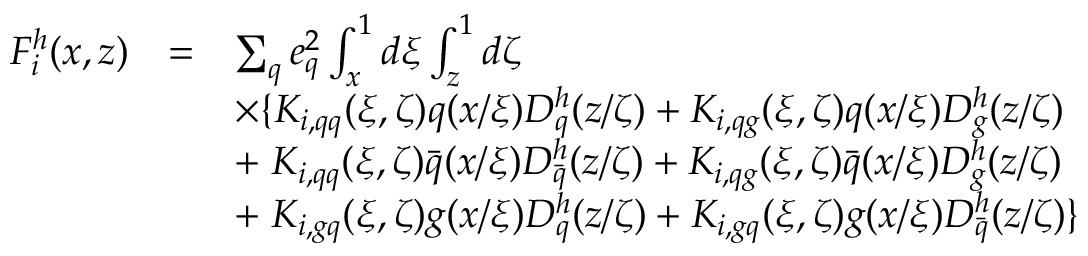Convert formula to latex. <formula><loc_0><loc_0><loc_500><loc_500>\begin{array} { r c l } { { F _ { i } ^ { h } ( x , z ) } } & { = } & { { \sum _ { q } e _ { q } ^ { 2 } \int _ { x } ^ { 1 } d \xi \int _ { z } ^ { 1 } d \zeta } } & { { \times \{ K _ { i , q q } ( \xi , \zeta ) q ( x / \xi ) D _ { q } ^ { h } ( z / \zeta ) + K _ { i , q g } ( \xi , \zeta ) q ( x / \xi ) D _ { g } ^ { h } ( z / \zeta ) } } & { { + \, K _ { i , q q } ( \xi , \zeta ) \bar { q } ( x / \xi ) D _ { \bar { q } } ^ { h } ( z / \zeta ) + K _ { i , q g } ( \xi , \zeta ) \bar { q } ( x / \xi ) D _ { g } ^ { h } ( z / \zeta ) } } & { { + \, K _ { i , g q } ( \xi , \zeta ) g ( x / \xi ) D _ { q } ^ { h } ( z / \zeta ) + K _ { i , g q } ( \xi , \zeta ) g ( x / \xi ) D _ { \bar { q } } ^ { h } ( z / \zeta ) \} } } \end{array}</formula> 